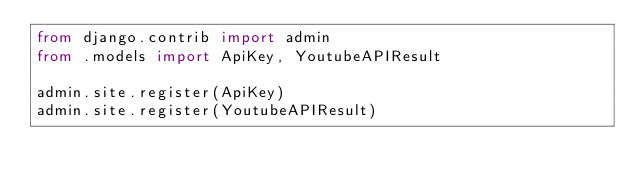<code> <loc_0><loc_0><loc_500><loc_500><_Python_>from django.contrib import admin
from .models import ApiKey, YoutubeAPIResult

admin.site.register(ApiKey)
admin.site.register(YoutubeAPIResult)
</code> 